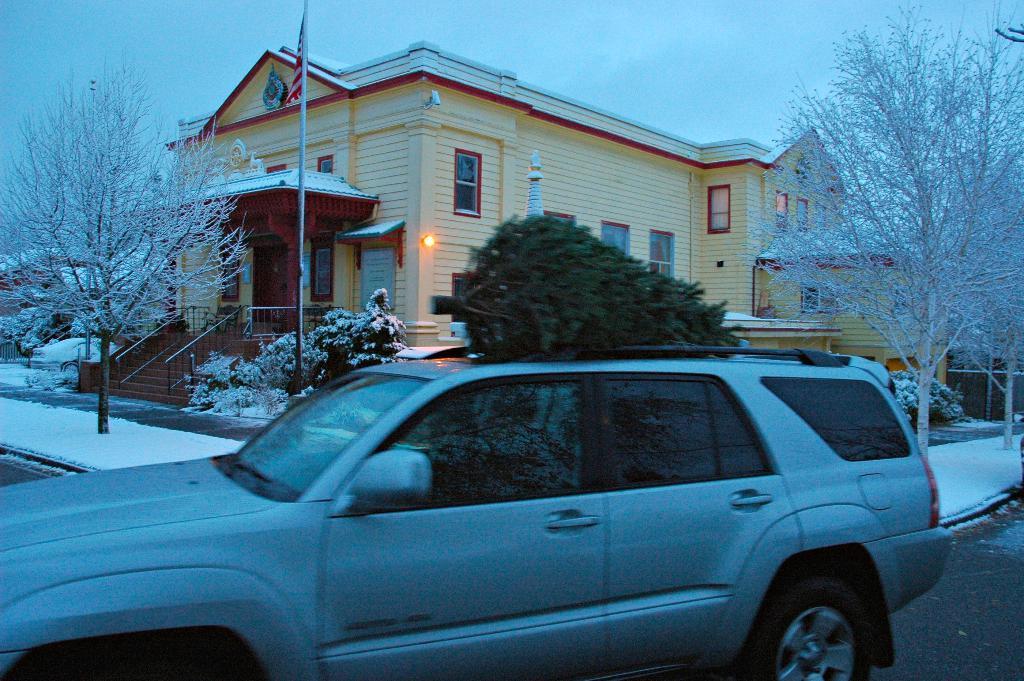Could you give a brief overview of what you see in this image? This is the picture of a place where we have a house, car, poles, trees and some snow around. 